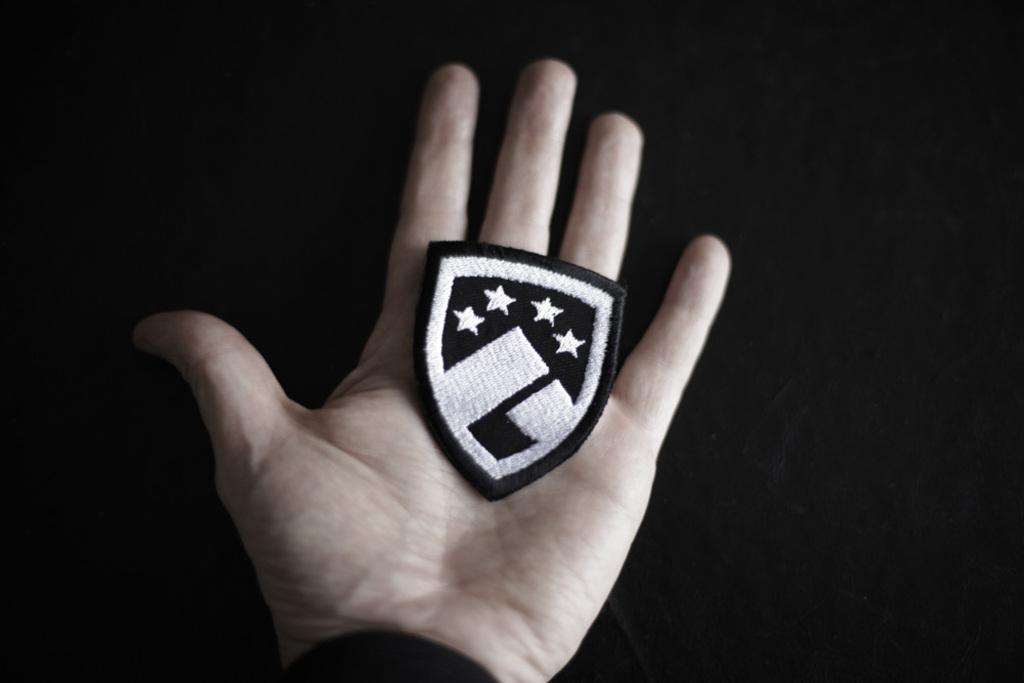What is the main subject of the image? The main subject of the image is a person's hand. What is the hand holding in the image? The hand is holding a black color emblem. What is the color of the background in the image? The background of the image is in black color. Can you observe any sparks coming from the hand in the image? There are no sparks present in the image. What is the person in the image about to start doing? There is no indication of any action or activity being started in the image. 